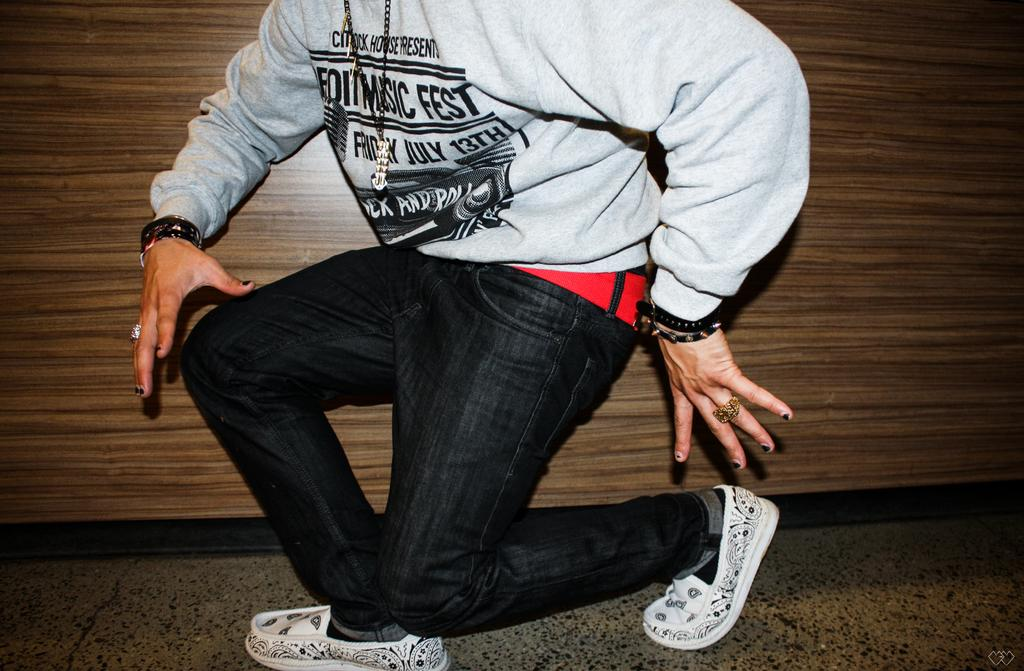Who or what is the main subject in the center of the image? There is a person in the center of the image. What is the position of the person in the image? The person is on the floor. What type of wall can be seen in the background of the image? There is a wooden wall in the background of the image. What type of jam is being spread on the rock in the image? There is no rock or jam present in the image. 